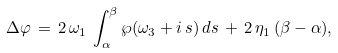<formula> <loc_0><loc_0><loc_500><loc_500>\Delta \varphi \, = \, 2 \, \omega _ { 1 } \, \int _ { \alpha } ^ { \beta } \wp ( \omega _ { 3 } + i \, s ) \, d s \, + \, 2 \, \eta _ { 1 } \, ( \beta - \alpha ) ,</formula> 